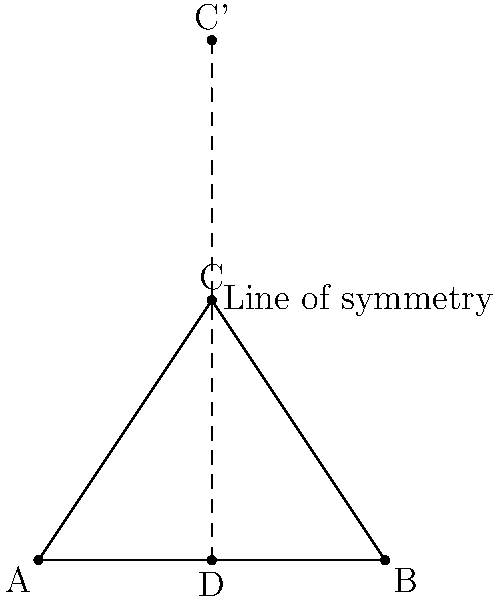A spiritual symbol is represented by an isosceles triangle ABC, where AB is the base and C is the apex. If the triangle is reflected across the line of symmetry passing through the midpoint of AB and the apex C, what are the coordinates of the reflected point C' if A is at (0,0), B is at (4,0), and C is at (2,3)? Let's approach this step-by-step:

1) The line of symmetry passes through the midpoint of AB and point C. The midpoint D of AB is at (2,0).

2) The line of symmetry is therefore the vertical line x = 2.

3) To find the reflection of point C across this line, we need to determine how far C is from the line of symmetry and extend that same distance on the other side.

4) The x-coordinate of C is already 2, which is on the line of symmetry. So the x-coordinate of C' will also be 2.

5) The y-coordinate of C is 3. Since C is already on the line of symmetry (with respect to x), its reflection C' will have the same distance above the x-axis, but doubled.

6) Therefore, the y-coordinate of C' will be 3 + 3 = 6.

Thus, the coordinates of C' will be (2,6).
Answer: (2,6) 